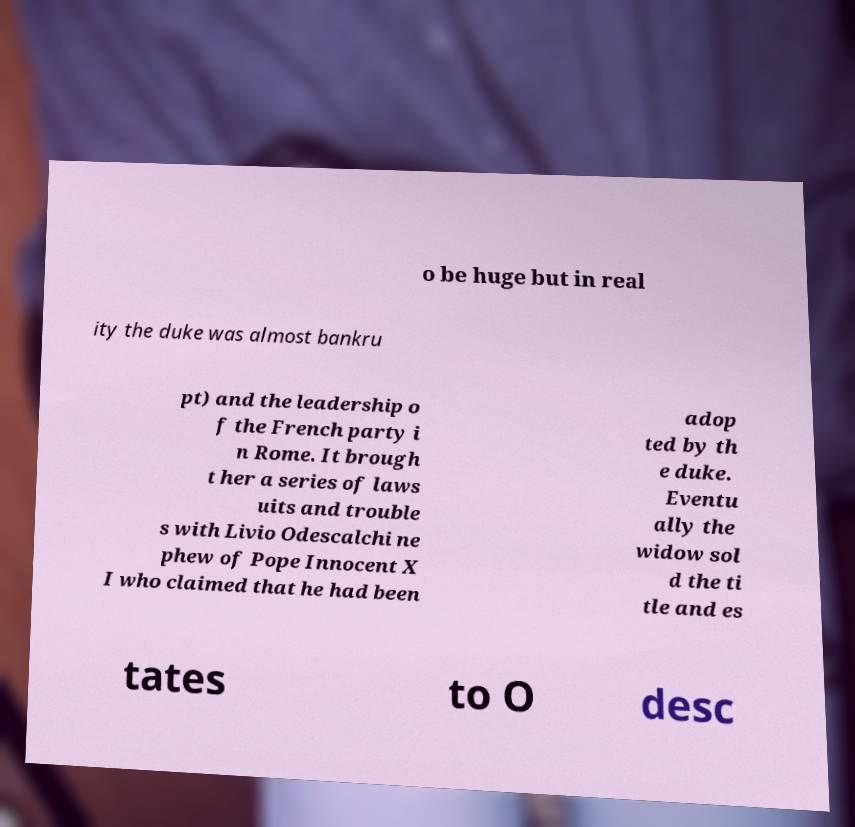Can you read and provide the text displayed in the image?This photo seems to have some interesting text. Can you extract and type it out for me? o be huge but in real ity the duke was almost bankru pt) and the leadership o f the French party i n Rome. It brough t her a series of laws uits and trouble s with Livio Odescalchi ne phew of Pope Innocent X I who claimed that he had been adop ted by th e duke. Eventu ally the widow sol d the ti tle and es tates to O desc 